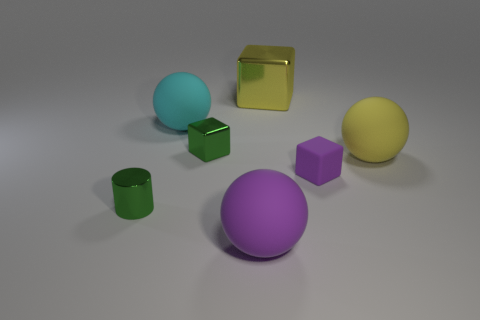Subtract all tiny matte blocks. How many blocks are left? 2 Subtract 1 balls. How many balls are left? 2 Add 2 yellow cubes. How many objects exist? 9 Subtract all cylinders. How many objects are left? 6 Subtract all red cubes. Subtract all blue cylinders. How many cubes are left? 3 Add 1 small red rubber cylinders. How many small red rubber cylinders exist? 1 Subtract 0 yellow cylinders. How many objects are left? 7 Subtract all metal cylinders. Subtract all purple cubes. How many objects are left? 5 Add 2 cylinders. How many cylinders are left? 3 